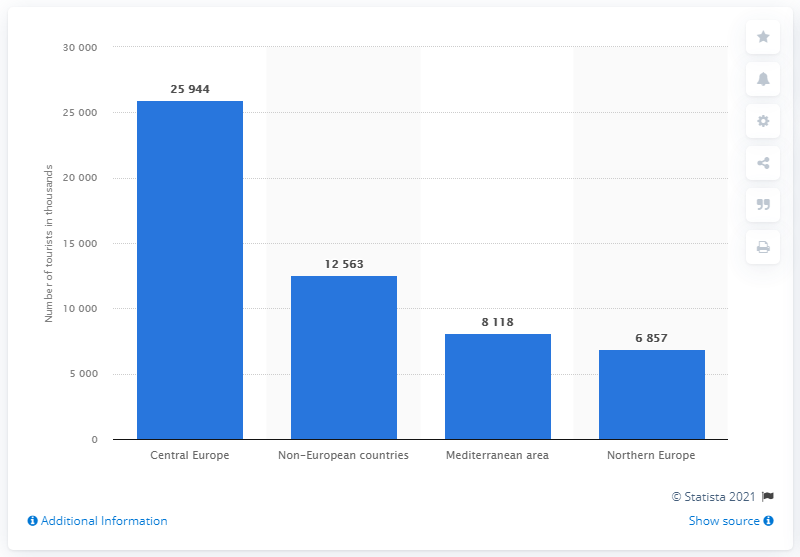Mention a couple of crucial points in this snapshot. The majority of inbound tourists in Italy originate from Central Europe. 